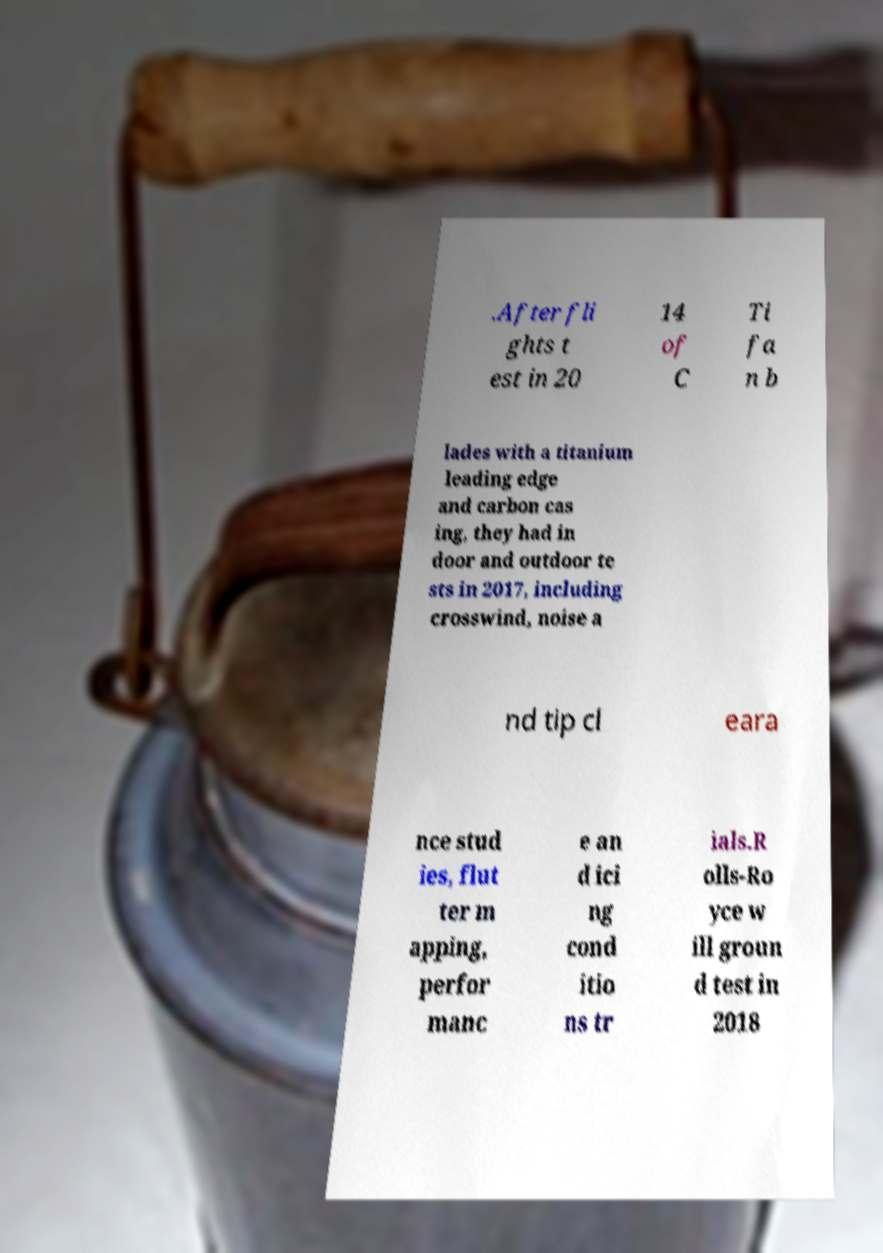Can you accurately transcribe the text from the provided image for me? .After fli ghts t est in 20 14 of C Ti fa n b lades with a titanium leading edge and carbon cas ing, they had in door and outdoor te sts in 2017, including crosswind, noise a nd tip cl eara nce stud ies, flut ter m apping, perfor manc e an d ici ng cond itio ns tr ials.R olls-Ro yce w ill groun d test in 2018 